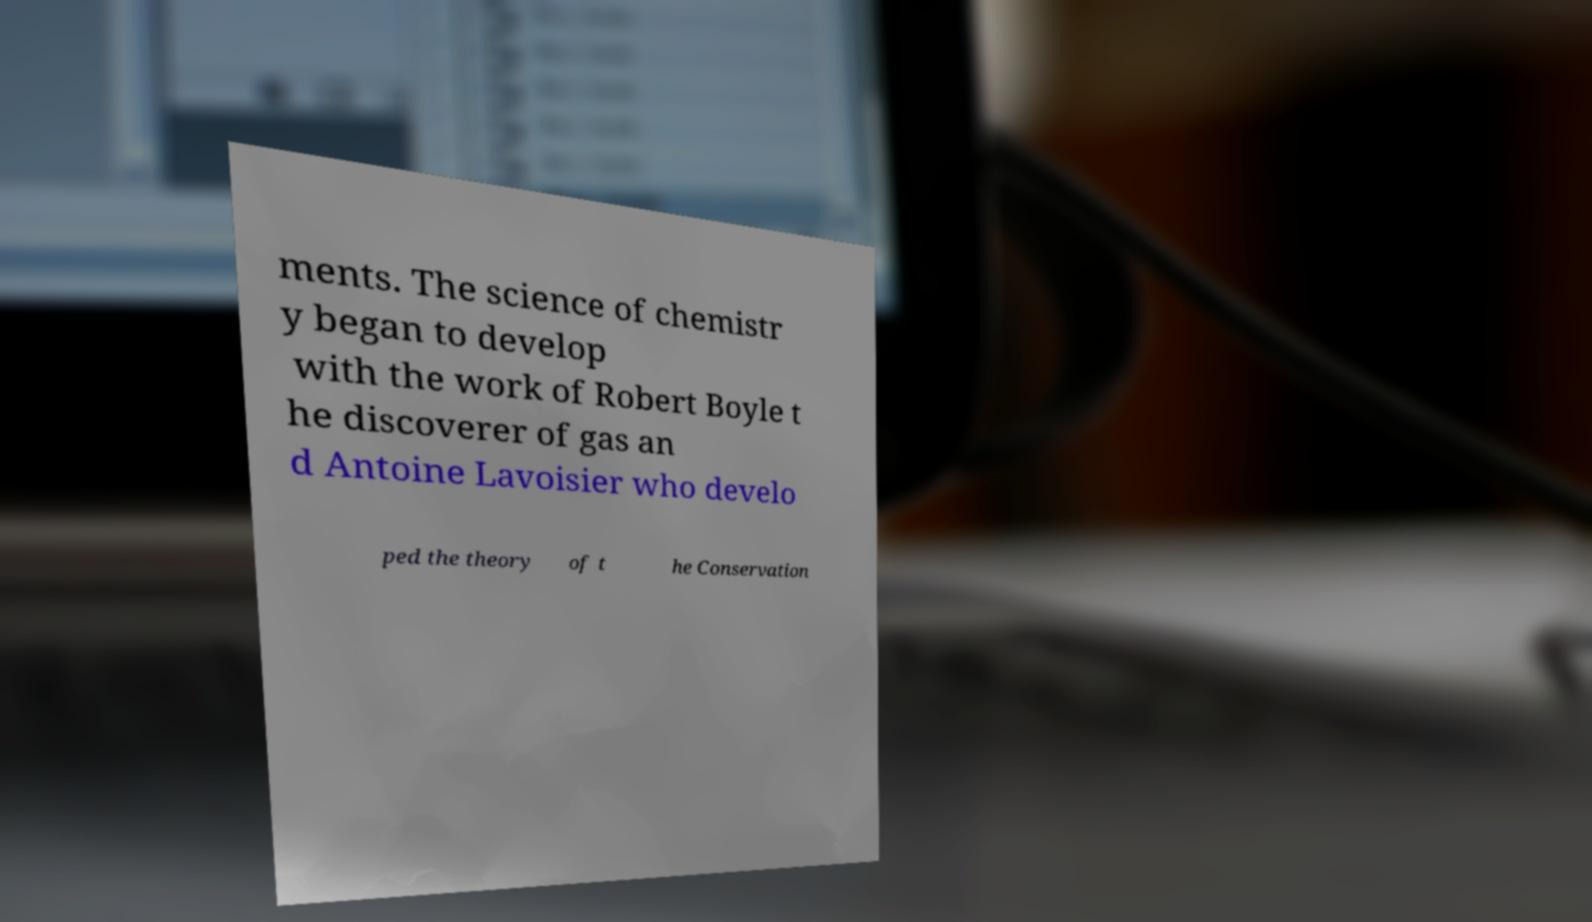There's text embedded in this image that I need extracted. Can you transcribe it verbatim? ments. The science of chemistr y began to develop with the work of Robert Boyle t he discoverer of gas an d Antoine Lavoisier who develo ped the theory of t he Conservation 